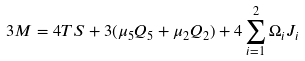<formula> <loc_0><loc_0><loc_500><loc_500>3 M = 4 T S + 3 ( \mu _ { 5 } Q _ { 5 } + \mu _ { 2 } Q _ { 2 } ) + 4 \sum _ { i = 1 } ^ { 2 } \Omega _ { i } J _ { i }</formula> 